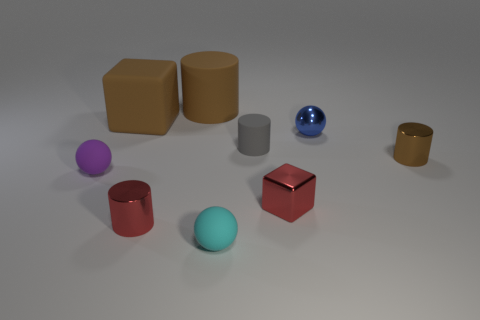How would you describe the size relationship among these objects? The objects vary in size, with a couple of larger cylindrical shapes that seem significantly bigger than the smaller spheres and cubes. The varying sizes give the impression of a comparative display or perhaps a study in geometry. 